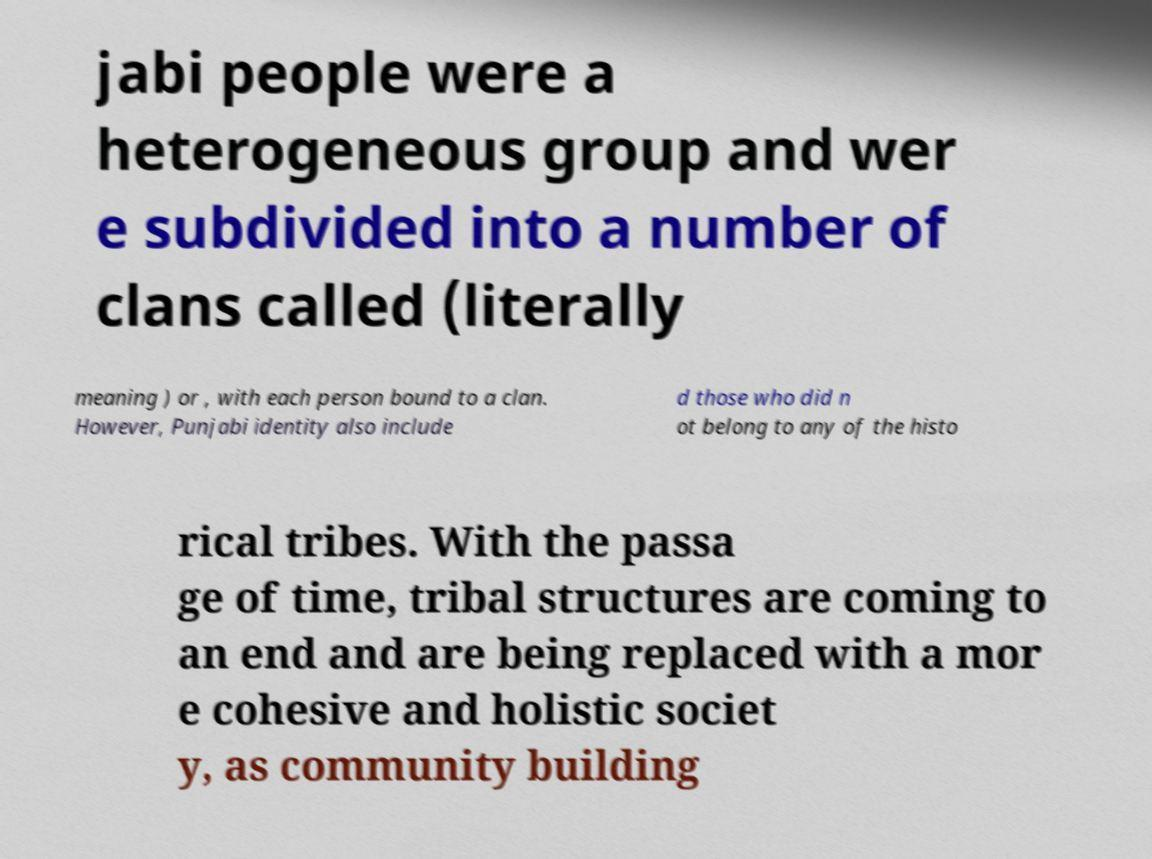Can you read and provide the text displayed in the image?This photo seems to have some interesting text. Can you extract and type it out for me? jabi people were a heterogeneous group and wer e subdivided into a number of clans called (literally meaning ) or , with each person bound to a clan. However, Punjabi identity also include d those who did n ot belong to any of the histo rical tribes. With the passa ge of time, tribal structures are coming to an end and are being replaced with a mor e cohesive and holistic societ y, as community building 